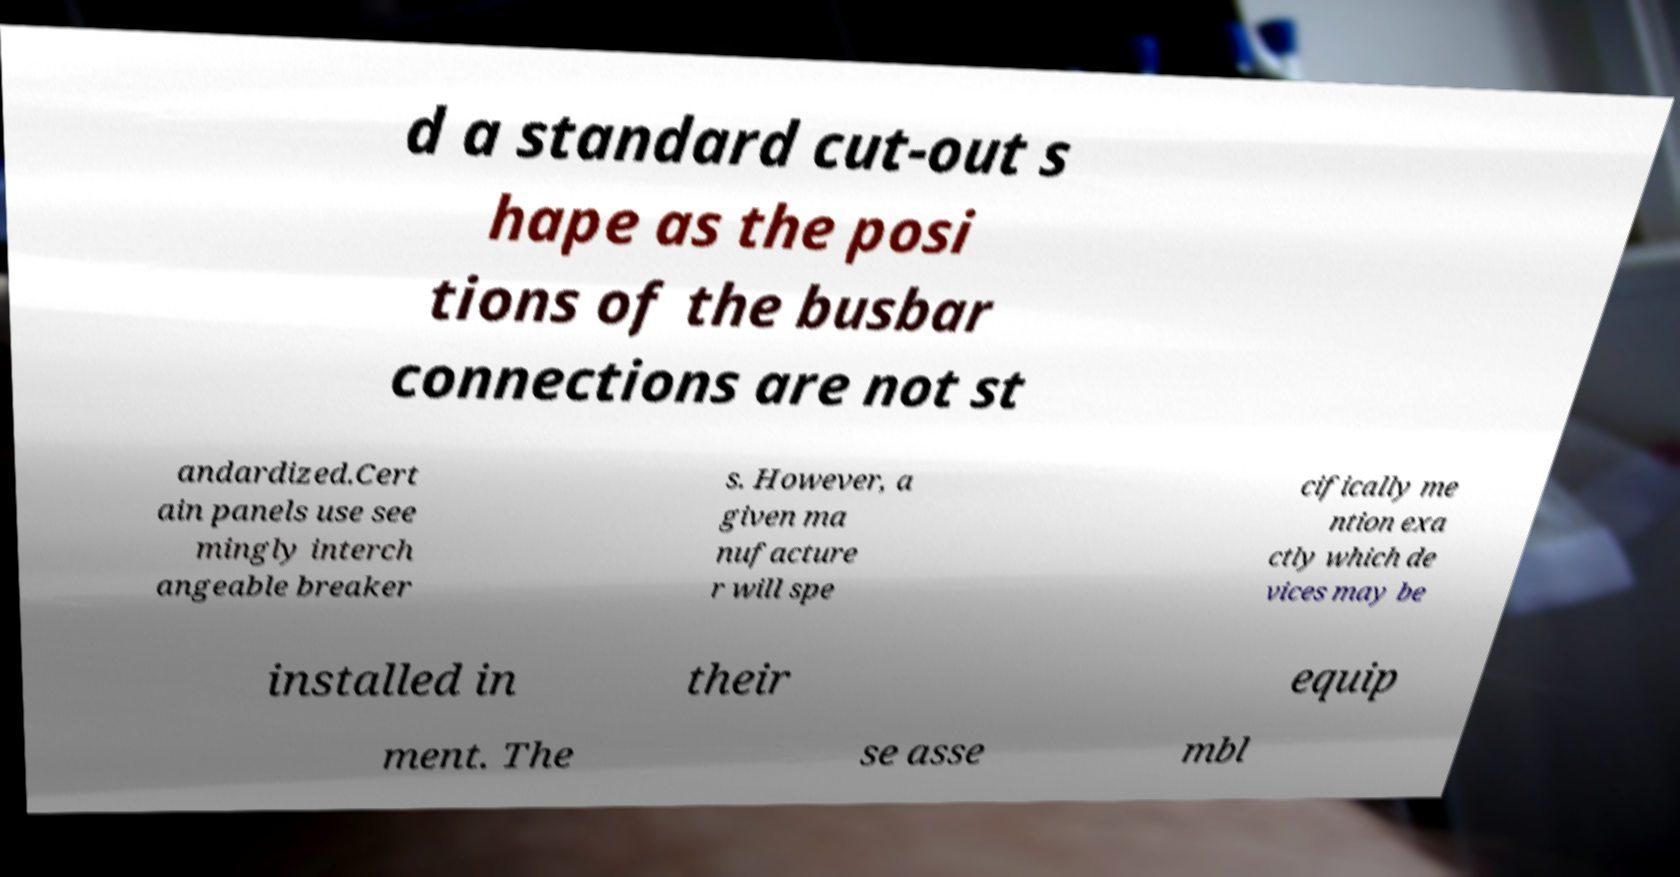Can you read and provide the text displayed in the image?This photo seems to have some interesting text. Can you extract and type it out for me? d a standard cut-out s hape as the posi tions of the busbar connections are not st andardized.Cert ain panels use see mingly interch angeable breaker s. However, a given ma nufacture r will spe cifically me ntion exa ctly which de vices may be installed in their equip ment. The se asse mbl 